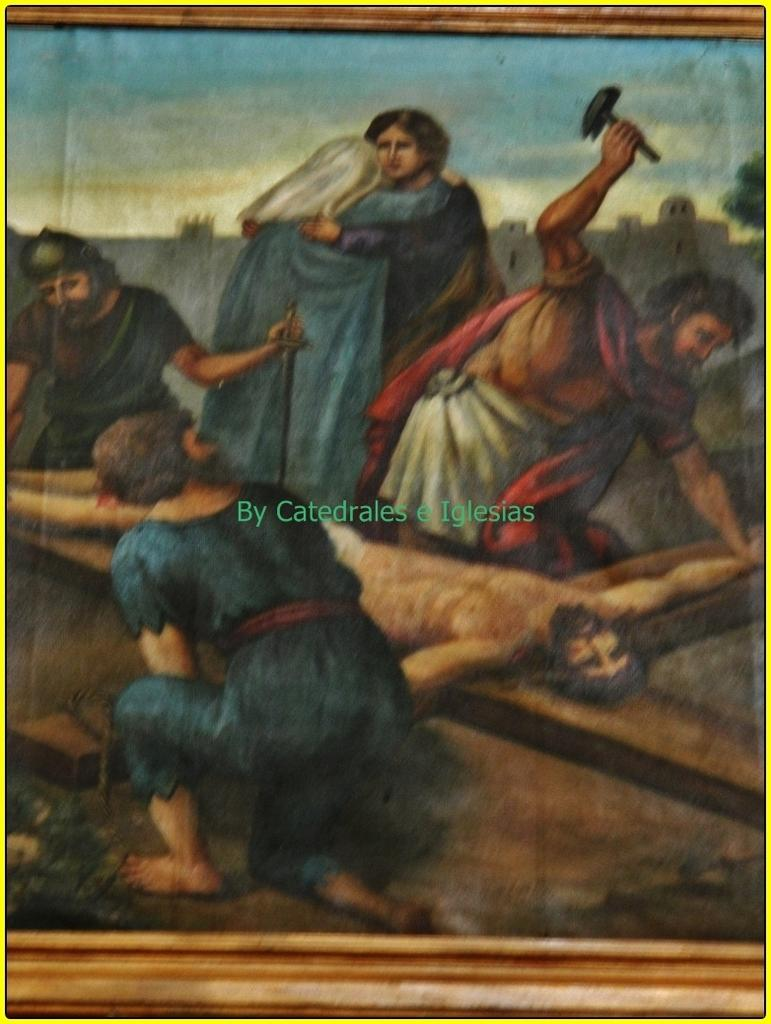What is the main subject of the image? The main subject of the image is a painting. Does the painting have any specific features? Yes, the painting has a frame. What else can be seen in the middle of the image? There is a watermark in the middle of the image. What type of church can be seen in the background of the image? There is no church present in the image; it features a painting with a frame and a watermark. What kind of breakfast is being prepared in the image? There is no breakfast preparation visible in the image; it only contains a painting with a frame and a watermark. 